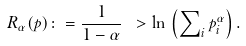<formula> <loc_0><loc_0><loc_500><loc_500>R _ { \alpha } ( p ) \colon = \frac { 1 } { 1 - \alpha } \ > \ln \, \left ( \sum \nolimits _ { i } p _ { i } ^ { \alpha } \right ) .</formula> 